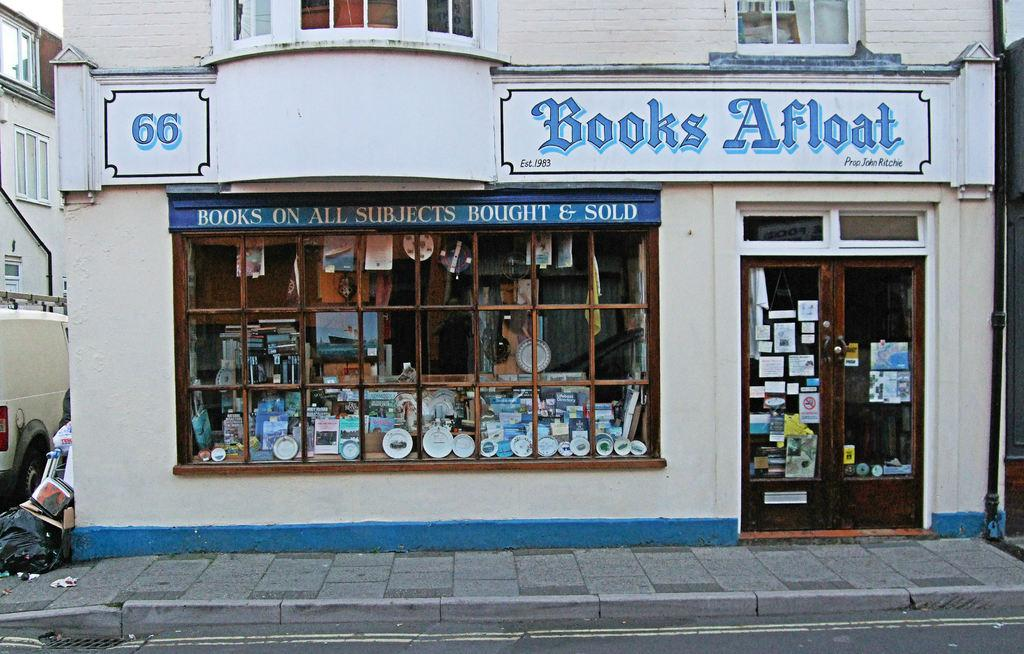Provide a one-sentence caption for the provided image. a store with a blue title that is called Books Afloat. 